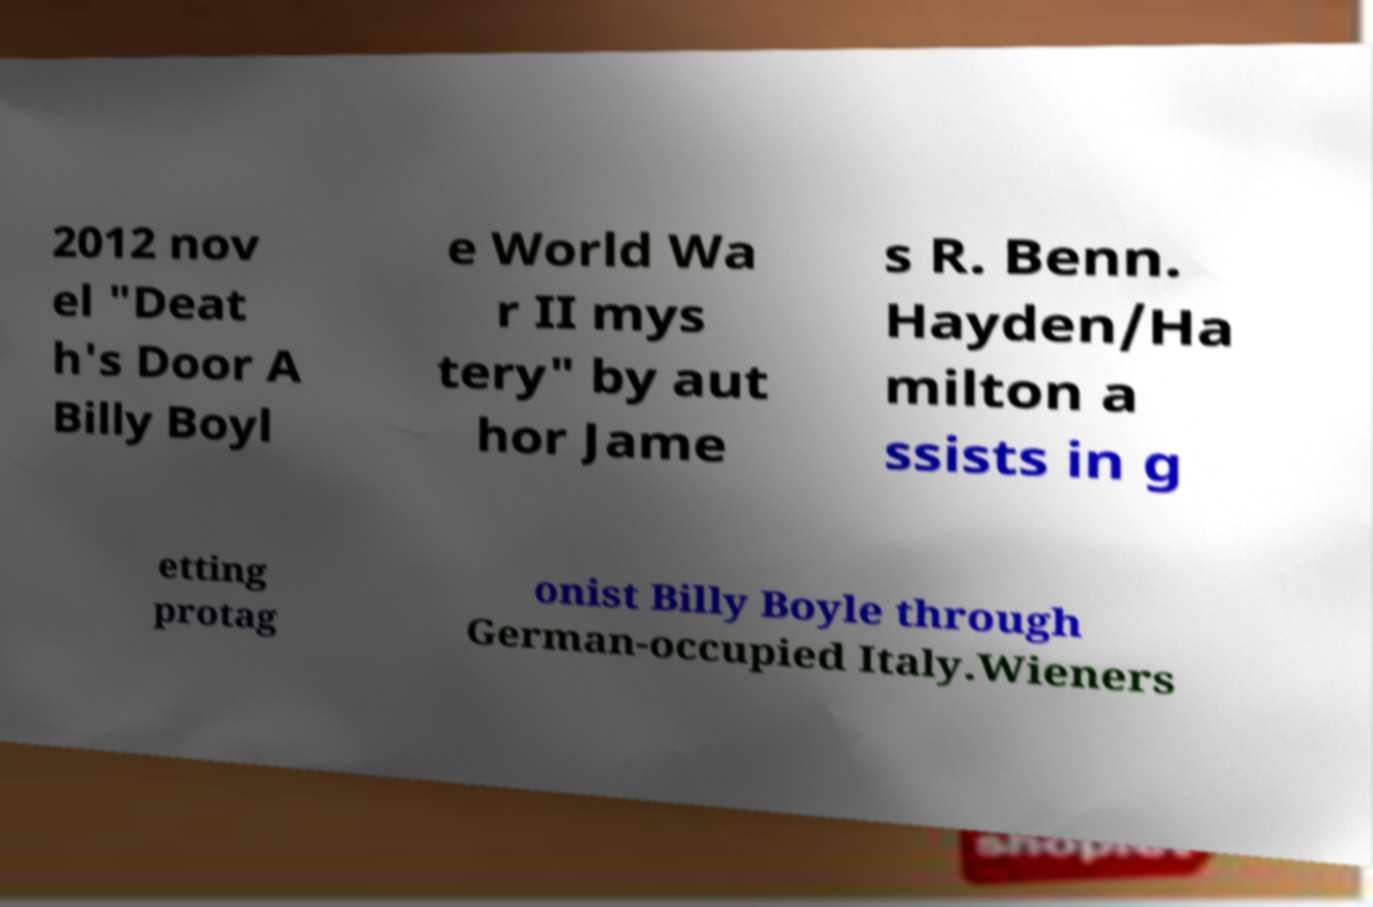Can you accurately transcribe the text from the provided image for me? 2012 nov el "Deat h's Door A Billy Boyl e World Wa r II mys tery" by aut hor Jame s R. Benn. Hayden/Ha milton a ssists in g etting protag onist Billy Boyle through German-occupied Italy.Wieners 